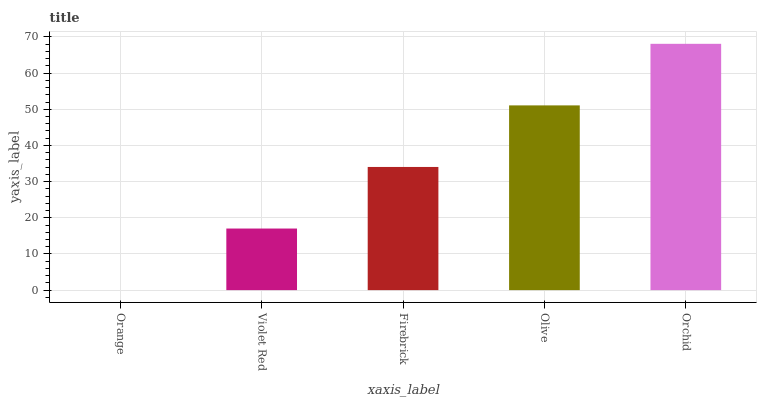Is Orange the minimum?
Answer yes or no. Yes. Is Orchid the maximum?
Answer yes or no. Yes. Is Violet Red the minimum?
Answer yes or no. No. Is Violet Red the maximum?
Answer yes or no. No. Is Violet Red greater than Orange?
Answer yes or no. Yes. Is Orange less than Violet Red?
Answer yes or no. Yes. Is Orange greater than Violet Red?
Answer yes or no. No. Is Violet Red less than Orange?
Answer yes or no. No. Is Firebrick the high median?
Answer yes or no. Yes. Is Firebrick the low median?
Answer yes or no. Yes. Is Orange the high median?
Answer yes or no. No. Is Orange the low median?
Answer yes or no. No. 